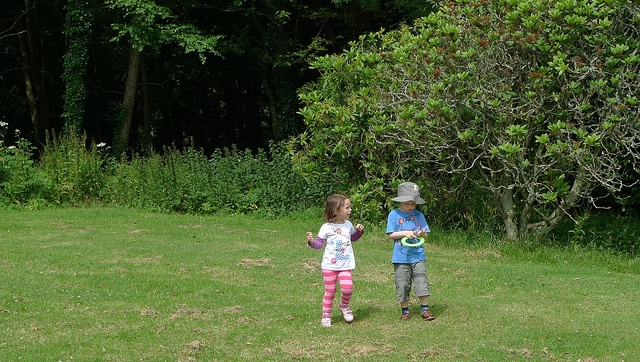Describe the objects in this image and their specific colors. I can see people in black, darkgray, gray, lightblue, and olive tones, people in black, lavender, brown, lightpink, and gray tones, and frisbee in black, lightyellow, teal, and lightgreen tones in this image. 